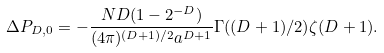<formula> <loc_0><loc_0><loc_500><loc_500>\, \Delta P _ { D , 0 } = - \frac { N D ( 1 - 2 ^ { - D } ) } { ( 4 \pi ) ^ { ( D + 1 ) / 2 } a ^ { D + 1 } } \Gamma ( ( D + 1 ) / 2 ) \zeta ( D + 1 ) .</formula> 